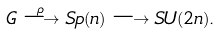Convert formula to latex. <formula><loc_0><loc_0><loc_500><loc_500>G \overset { \rho } { \longrightarrow } S p ( n ) \longrightarrow S U ( 2 n ) .</formula> 